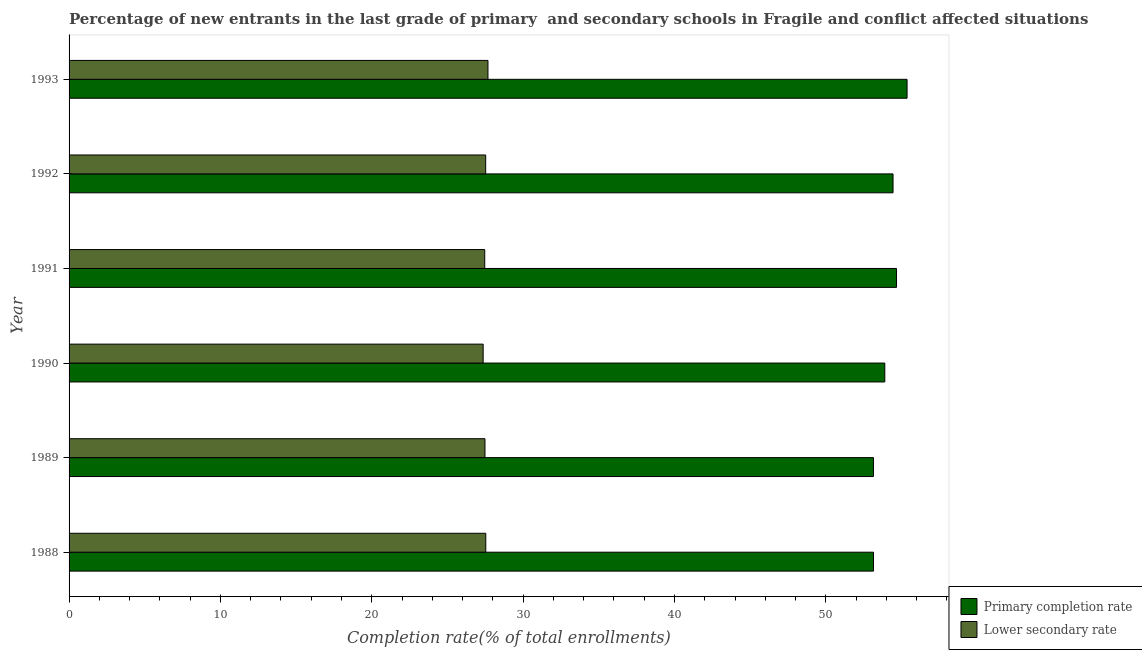How many different coloured bars are there?
Give a very brief answer. 2. How many groups of bars are there?
Provide a succinct answer. 6. Are the number of bars per tick equal to the number of legend labels?
Your response must be concise. Yes. In how many cases, is the number of bars for a given year not equal to the number of legend labels?
Your answer should be compact. 0. What is the completion rate in primary schools in 1990?
Give a very brief answer. 53.9. Across all years, what is the maximum completion rate in secondary schools?
Provide a short and direct response. 27.68. Across all years, what is the minimum completion rate in secondary schools?
Your answer should be very brief. 27.36. In which year was the completion rate in primary schools maximum?
Your response must be concise. 1993. What is the total completion rate in secondary schools in the graph?
Ensure brevity in your answer.  165.04. What is the difference between the completion rate in secondary schools in 1990 and that in 1991?
Offer a very short reply. -0.1. What is the difference between the completion rate in primary schools in 1989 and the completion rate in secondary schools in 1988?
Provide a short and direct response. 25.61. What is the average completion rate in primary schools per year?
Provide a short and direct response. 54.11. In the year 1988, what is the difference between the completion rate in primary schools and completion rate in secondary schools?
Keep it short and to the point. 25.62. In how many years, is the completion rate in primary schools greater than 30 %?
Your answer should be very brief. 6. Is the difference between the completion rate in secondary schools in 1990 and 1992 greater than the difference between the completion rate in primary schools in 1990 and 1992?
Offer a very short reply. Yes. What is the difference between the highest and the second highest completion rate in primary schools?
Your answer should be very brief. 0.7. What is the difference between the highest and the lowest completion rate in primary schools?
Your answer should be compact. 2.22. In how many years, is the completion rate in secondary schools greater than the average completion rate in secondary schools taken over all years?
Your response must be concise. 3. What does the 2nd bar from the top in 1991 represents?
Keep it short and to the point. Primary completion rate. What does the 2nd bar from the bottom in 1988 represents?
Provide a short and direct response. Lower secondary rate. How many bars are there?
Your response must be concise. 12. Are all the bars in the graph horizontal?
Give a very brief answer. Yes. What is the difference between two consecutive major ticks on the X-axis?
Provide a short and direct response. 10. Are the values on the major ticks of X-axis written in scientific E-notation?
Your answer should be compact. No. Where does the legend appear in the graph?
Offer a very short reply. Bottom right. How are the legend labels stacked?
Offer a very short reply. Vertical. What is the title of the graph?
Provide a short and direct response. Percentage of new entrants in the last grade of primary  and secondary schools in Fragile and conflict affected situations. Does "Non-solid fuel" appear as one of the legend labels in the graph?
Make the answer very short. No. What is the label or title of the X-axis?
Keep it short and to the point. Completion rate(% of total enrollments). What is the label or title of the Y-axis?
Your response must be concise. Year. What is the Completion rate(% of total enrollments) of Primary completion rate in 1988?
Your response must be concise. 53.15. What is the Completion rate(% of total enrollments) in Lower secondary rate in 1988?
Provide a succinct answer. 27.53. What is the Completion rate(% of total enrollments) of Primary completion rate in 1989?
Give a very brief answer. 53.15. What is the Completion rate(% of total enrollments) in Lower secondary rate in 1989?
Provide a succinct answer. 27.48. What is the Completion rate(% of total enrollments) in Primary completion rate in 1990?
Provide a succinct answer. 53.9. What is the Completion rate(% of total enrollments) of Lower secondary rate in 1990?
Give a very brief answer. 27.36. What is the Completion rate(% of total enrollments) in Primary completion rate in 1991?
Your answer should be compact. 54.67. What is the Completion rate(% of total enrollments) of Lower secondary rate in 1991?
Your answer should be compact. 27.46. What is the Completion rate(% of total enrollments) of Primary completion rate in 1992?
Provide a succinct answer. 54.44. What is the Completion rate(% of total enrollments) in Lower secondary rate in 1992?
Ensure brevity in your answer.  27.53. What is the Completion rate(% of total enrollments) in Primary completion rate in 1993?
Ensure brevity in your answer.  55.37. What is the Completion rate(% of total enrollments) in Lower secondary rate in 1993?
Offer a very short reply. 27.68. Across all years, what is the maximum Completion rate(% of total enrollments) in Primary completion rate?
Provide a succinct answer. 55.37. Across all years, what is the maximum Completion rate(% of total enrollments) in Lower secondary rate?
Give a very brief answer. 27.68. Across all years, what is the minimum Completion rate(% of total enrollments) of Primary completion rate?
Provide a succinct answer. 53.15. Across all years, what is the minimum Completion rate(% of total enrollments) in Lower secondary rate?
Your answer should be very brief. 27.36. What is the total Completion rate(% of total enrollments) of Primary completion rate in the graph?
Provide a short and direct response. 324.68. What is the total Completion rate(% of total enrollments) in Lower secondary rate in the graph?
Offer a terse response. 165.04. What is the difference between the Completion rate(% of total enrollments) in Primary completion rate in 1988 and that in 1989?
Your answer should be compact. 0. What is the difference between the Completion rate(% of total enrollments) in Lower secondary rate in 1988 and that in 1989?
Make the answer very short. 0.05. What is the difference between the Completion rate(% of total enrollments) of Primary completion rate in 1988 and that in 1990?
Offer a terse response. -0.75. What is the difference between the Completion rate(% of total enrollments) of Lower secondary rate in 1988 and that in 1990?
Make the answer very short. 0.17. What is the difference between the Completion rate(% of total enrollments) in Primary completion rate in 1988 and that in 1991?
Give a very brief answer. -1.52. What is the difference between the Completion rate(% of total enrollments) in Lower secondary rate in 1988 and that in 1991?
Offer a very short reply. 0.07. What is the difference between the Completion rate(% of total enrollments) of Primary completion rate in 1988 and that in 1992?
Offer a very short reply. -1.29. What is the difference between the Completion rate(% of total enrollments) of Lower secondary rate in 1988 and that in 1992?
Provide a succinct answer. 0.01. What is the difference between the Completion rate(% of total enrollments) in Primary completion rate in 1988 and that in 1993?
Provide a succinct answer. -2.22. What is the difference between the Completion rate(% of total enrollments) in Lower secondary rate in 1988 and that in 1993?
Provide a succinct answer. -0.14. What is the difference between the Completion rate(% of total enrollments) of Primary completion rate in 1989 and that in 1990?
Offer a terse response. -0.75. What is the difference between the Completion rate(% of total enrollments) in Lower secondary rate in 1989 and that in 1990?
Your answer should be very brief. 0.12. What is the difference between the Completion rate(% of total enrollments) in Primary completion rate in 1989 and that in 1991?
Your answer should be very brief. -1.52. What is the difference between the Completion rate(% of total enrollments) in Lower secondary rate in 1989 and that in 1991?
Your answer should be compact. 0.02. What is the difference between the Completion rate(% of total enrollments) of Primary completion rate in 1989 and that in 1992?
Make the answer very short. -1.29. What is the difference between the Completion rate(% of total enrollments) of Lower secondary rate in 1989 and that in 1992?
Your response must be concise. -0.05. What is the difference between the Completion rate(% of total enrollments) of Primary completion rate in 1989 and that in 1993?
Offer a very short reply. -2.22. What is the difference between the Completion rate(% of total enrollments) of Lower secondary rate in 1989 and that in 1993?
Keep it short and to the point. -0.2. What is the difference between the Completion rate(% of total enrollments) of Primary completion rate in 1990 and that in 1991?
Ensure brevity in your answer.  -0.77. What is the difference between the Completion rate(% of total enrollments) in Lower secondary rate in 1990 and that in 1991?
Your answer should be compact. -0.1. What is the difference between the Completion rate(% of total enrollments) of Primary completion rate in 1990 and that in 1992?
Your response must be concise. -0.54. What is the difference between the Completion rate(% of total enrollments) in Lower secondary rate in 1990 and that in 1992?
Offer a very short reply. -0.17. What is the difference between the Completion rate(% of total enrollments) in Primary completion rate in 1990 and that in 1993?
Offer a very short reply. -1.47. What is the difference between the Completion rate(% of total enrollments) of Lower secondary rate in 1990 and that in 1993?
Your answer should be very brief. -0.32. What is the difference between the Completion rate(% of total enrollments) of Primary completion rate in 1991 and that in 1992?
Ensure brevity in your answer.  0.23. What is the difference between the Completion rate(% of total enrollments) of Lower secondary rate in 1991 and that in 1992?
Give a very brief answer. -0.06. What is the difference between the Completion rate(% of total enrollments) of Primary completion rate in 1991 and that in 1993?
Your response must be concise. -0.7. What is the difference between the Completion rate(% of total enrollments) in Lower secondary rate in 1991 and that in 1993?
Ensure brevity in your answer.  -0.21. What is the difference between the Completion rate(% of total enrollments) of Primary completion rate in 1992 and that in 1993?
Your answer should be very brief. -0.93. What is the difference between the Completion rate(% of total enrollments) in Lower secondary rate in 1992 and that in 1993?
Offer a terse response. -0.15. What is the difference between the Completion rate(% of total enrollments) in Primary completion rate in 1988 and the Completion rate(% of total enrollments) in Lower secondary rate in 1989?
Keep it short and to the point. 25.67. What is the difference between the Completion rate(% of total enrollments) in Primary completion rate in 1988 and the Completion rate(% of total enrollments) in Lower secondary rate in 1990?
Provide a short and direct response. 25.79. What is the difference between the Completion rate(% of total enrollments) in Primary completion rate in 1988 and the Completion rate(% of total enrollments) in Lower secondary rate in 1991?
Keep it short and to the point. 25.69. What is the difference between the Completion rate(% of total enrollments) of Primary completion rate in 1988 and the Completion rate(% of total enrollments) of Lower secondary rate in 1992?
Provide a short and direct response. 25.62. What is the difference between the Completion rate(% of total enrollments) in Primary completion rate in 1988 and the Completion rate(% of total enrollments) in Lower secondary rate in 1993?
Offer a terse response. 25.47. What is the difference between the Completion rate(% of total enrollments) in Primary completion rate in 1989 and the Completion rate(% of total enrollments) in Lower secondary rate in 1990?
Offer a terse response. 25.79. What is the difference between the Completion rate(% of total enrollments) of Primary completion rate in 1989 and the Completion rate(% of total enrollments) of Lower secondary rate in 1991?
Make the answer very short. 25.68. What is the difference between the Completion rate(% of total enrollments) in Primary completion rate in 1989 and the Completion rate(% of total enrollments) in Lower secondary rate in 1992?
Your answer should be compact. 25.62. What is the difference between the Completion rate(% of total enrollments) of Primary completion rate in 1989 and the Completion rate(% of total enrollments) of Lower secondary rate in 1993?
Your response must be concise. 25.47. What is the difference between the Completion rate(% of total enrollments) of Primary completion rate in 1990 and the Completion rate(% of total enrollments) of Lower secondary rate in 1991?
Your response must be concise. 26.43. What is the difference between the Completion rate(% of total enrollments) of Primary completion rate in 1990 and the Completion rate(% of total enrollments) of Lower secondary rate in 1992?
Make the answer very short. 26.37. What is the difference between the Completion rate(% of total enrollments) in Primary completion rate in 1990 and the Completion rate(% of total enrollments) in Lower secondary rate in 1993?
Offer a very short reply. 26.22. What is the difference between the Completion rate(% of total enrollments) of Primary completion rate in 1991 and the Completion rate(% of total enrollments) of Lower secondary rate in 1992?
Offer a very short reply. 27.14. What is the difference between the Completion rate(% of total enrollments) in Primary completion rate in 1991 and the Completion rate(% of total enrollments) in Lower secondary rate in 1993?
Make the answer very short. 26.99. What is the difference between the Completion rate(% of total enrollments) in Primary completion rate in 1992 and the Completion rate(% of total enrollments) in Lower secondary rate in 1993?
Offer a very short reply. 26.76. What is the average Completion rate(% of total enrollments) in Primary completion rate per year?
Ensure brevity in your answer.  54.11. What is the average Completion rate(% of total enrollments) of Lower secondary rate per year?
Your answer should be very brief. 27.51. In the year 1988, what is the difference between the Completion rate(% of total enrollments) in Primary completion rate and Completion rate(% of total enrollments) in Lower secondary rate?
Keep it short and to the point. 25.62. In the year 1989, what is the difference between the Completion rate(% of total enrollments) of Primary completion rate and Completion rate(% of total enrollments) of Lower secondary rate?
Provide a succinct answer. 25.67. In the year 1990, what is the difference between the Completion rate(% of total enrollments) of Primary completion rate and Completion rate(% of total enrollments) of Lower secondary rate?
Offer a terse response. 26.54. In the year 1991, what is the difference between the Completion rate(% of total enrollments) of Primary completion rate and Completion rate(% of total enrollments) of Lower secondary rate?
Make the answer very short. 27.21. In the year 1992, what is the difference between the Completion rate(% of total enrollments) in Primary completion rate and Completion rate(% of total enrollments) in Lower secondary rate?
Keep it short and to the point. 26.91. In the year 1993, what is the difference between the Completion rate(% of total enrollments) in Primary completion rate and Completion rate(% of total enrollments) in Lower secondary rate?
Ensure brevity in your answer.  27.69. What is the ratio of the Completion rate(% of total enrollments) of Primary completion rate in 1988 to that in 1989?
Your answer should be compact. 1. What is the ratio of the Completion rate(% of total enrollments) in Primary completion rate in 1988 to that in 1990?
Your response must be concise. 0.99. What is the ratio of the Completion rate(% of total enrollments) in Primary completion rate in 1988 to that in 1991?
Offer a terse response. 0.97. What is the ratio of the Completion rate(% of total enrollments) of Lower secondary rate in 1988 to that in 1991?
Your answer should be compact. 1. What is the ratio of the Completion rate(% of total enrollments) in Primary completion rate in 1988 to that in 1992?
Offer a very short reply. 0.98. What is the ratio of the Completion rate(% of total enrollments) in Lower secondary rate in 1988 to that in 1992?
Give a very brief answer. 1. What is the ratio of the Completion rate(% of total enrollments) in Primary completion rate in 1988 to that in 1993?
Offer a terse response. 0.96. What is the ratio of the Completion rate(% of total enrollments) in Lower secondary rate in 1988 to that in 1993?
Give a very brief answer. 0.99. What is the ratio of the Completion rate(% of total enrollments) of Primary completion rate in 1989 to that in 1990?
Ensure brevity in your answer.  0.99. What is the ratio of the Completion rate(% of total enrollments) of Lower secondary rate in 1989 to that in 1990?
Give a very brief answer. 1. What is the ratio of the Completion rate(% of total enrollments) in Primary completion rate in 1989 to that in 1991?
Your response must be concise. 0.97. What is the ratio of the Completion rate(% of total enrollments) of Lower secondary rate in 1989 to that in 1991?
Keep it short and to the point. 1. What is the ratio of the Completion rate(% of total enrollments) in Primary completion rate in 1989 to that in 1992?
Ensure brevity in your answer.  0.98. What is the ratio of the Completion rate(% of total enrollments) of Lower secondary rate in 1989 to that in 1992?
Give a very brief answer. 1. What is the ratio of the Completion rate(% of total enrollments) of Primary completion rate in 1989 to that in 1993?
Your answer should be compact. 0.96. What is the ratio of the Completion rate(% of total enrollments) of Lower secondary rate in 1989 to that in 1993?
Your answer should be very brief. 0.99. What is the ratio of the Completion rate(% of total enrollments) of Primary completion rate in 1990 to that in 1991?
Keep it short and to the point. 0.99. What is the ratio of the Completion rate(% of total enrollments) of Lower secondary rate in 1990 to that in 1992?
Your response must be concise. 0.99. What is the ratio of the Completion rate(% of total enrollments) of Primary completion rate in 1990 to that in 1993?
Make the answer very short. 0.97. What is the ratio of the Completion rate(% of total enrollments) in Lower secondary rate in 1990 to that in 1993?
Make the answer very short. 0.99. What is the ratio of the Completion rate(% of total enrollments) in Primary completion rate in 1991 to that in 1993?
Give a very brief answer. 0.99. What is the ratio of the Completion rate(% of total enrollments) in Lower secondary rate in 1991 to that in 1993?
Give a very brief answer. 0.99. What is the ratio of the Completion rate(% of total enrollments) of Primary completion rate in 1992 to that in 1993?
Ensure brevity in your answer.  0.98. What is the ratio of the Completion rate(% of total enrollments) in Lower secondary rate in 1992 to that in 1993?
Your answer should be compact. 0.99. What is the difference between the highest and the second highest Completion rate(% of total enrollments) of Primary completion rate?
Your response must be concise. 0.7. What is the difference between the highest and the second highest Completion rate(% of total enrollments) in Lower secondary rate?
Your answer should be very brief. 0.14. What is the difference between the highest and the lowest Completion rate(% of total enrollments) of Primary completion rate?
Offer a terse response. 2.22. What is the difference between the highest and the lowest Completion rate(% of total enrollments) in Lower secondary rate?
Your response must be concise. 0.32. 